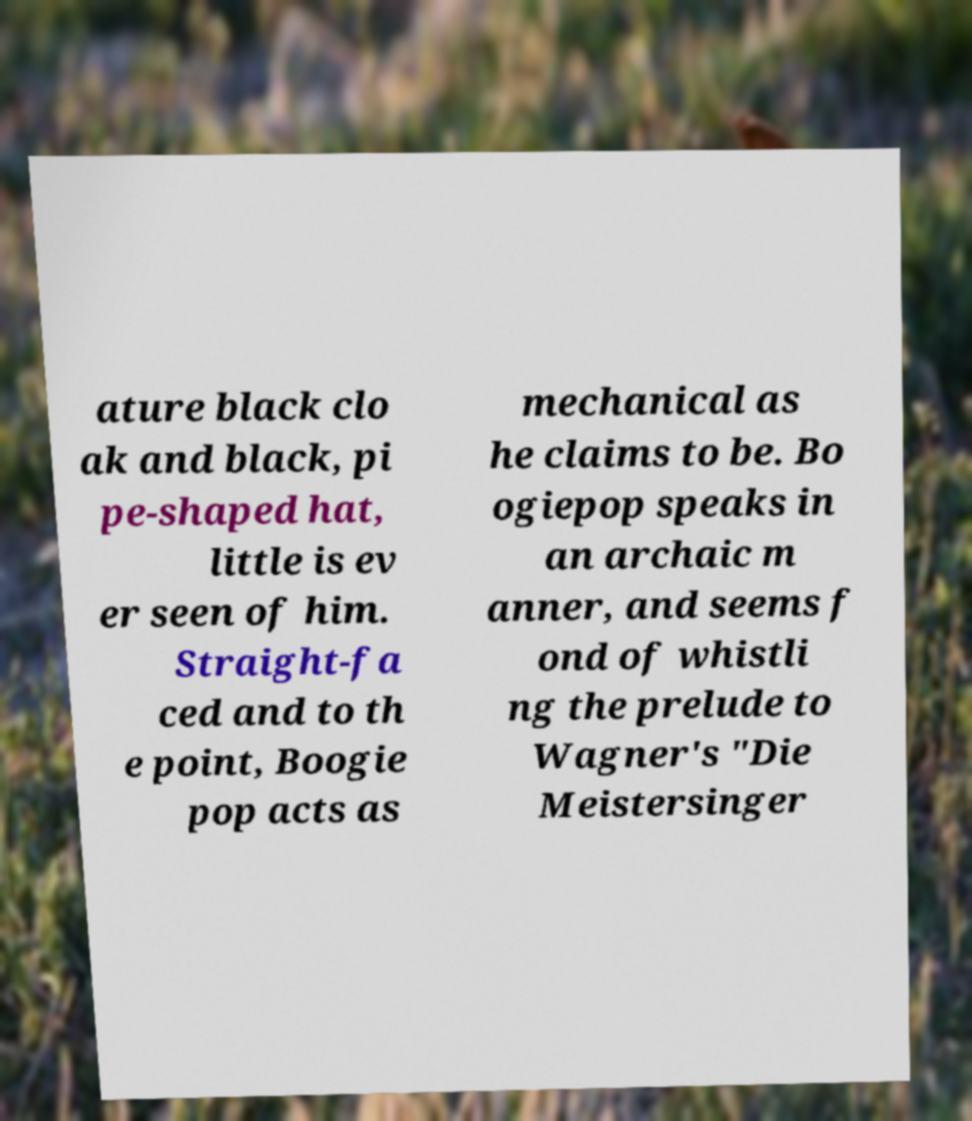Can you read and provide the text displayed in the image?This photo seems to have some interesting text. Can you extract and type it out for me? ature black clo ak and black, pi pe-shaped hat, little is ev er seen of him. Straight-fa ced and to th e point, Boogie pop acts as mechanical as he claims to be. Bo ogiepop speaks in an archaic m anner, and seems f ond of whistli ng the prelude to Wagner's "Die Meistersinger 